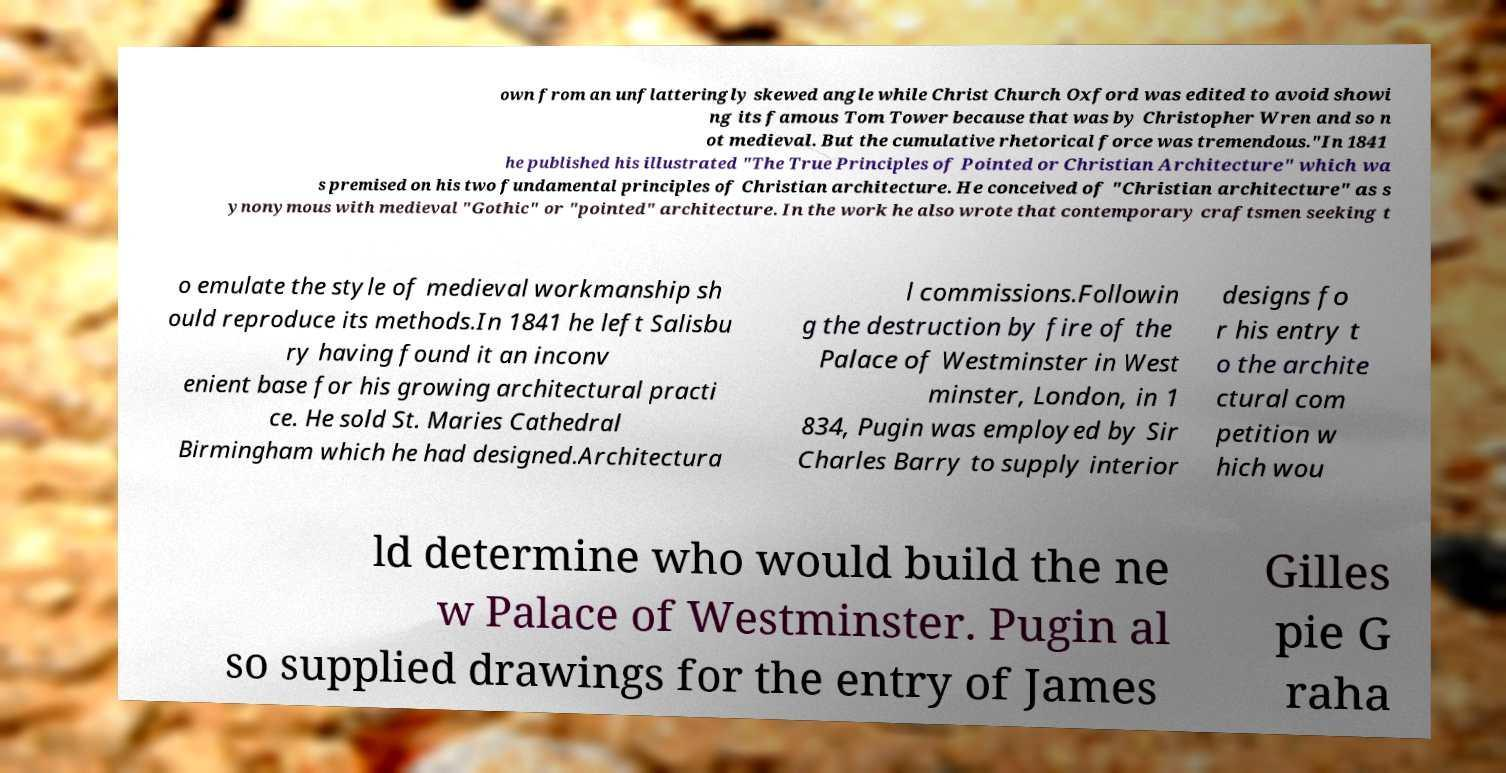For documentation purposes, I need the text within this image transcribed. Could you provide that? own from an unflatteringly skewed angle while Christ Church Oxford was edited to avoid showi ng its famous Tom Tower because that was by Christopher Wren and so n ot medieval. But the cumulative rhetorical force was tremendous."In 1841 he published his illustrated "The True Principles of Pointed or Christian Architecture" which wa s premised on his two fundamental principles of Christian architecture. He conceived of "Christian architecture" as s ynonymous with medieval "Gothic" or "pointed" architecture. In the work he also wrote that contemporary craftsmen seeking t o emulate the style of medieval workmanship sh ould reproduce its methods.In 1841 he left Salisbu ry having found it an inconv enient base for his growing architectural practi ce. He sold St. Maries Cathedral Birmingham which he had designed.Architectura l commissions.Followin g the destruction by fire of the Palace of Westminster in West minster, London, in 1 834, Pugin was employed by Sir Charles Barry to supply interior designs fo r his entry t o the archite ctural com petition w hich wou ld determine who would build the ne w Palace of Westminster. Pugin al so supplied drawings for the entry of James Gilles pie G raha 